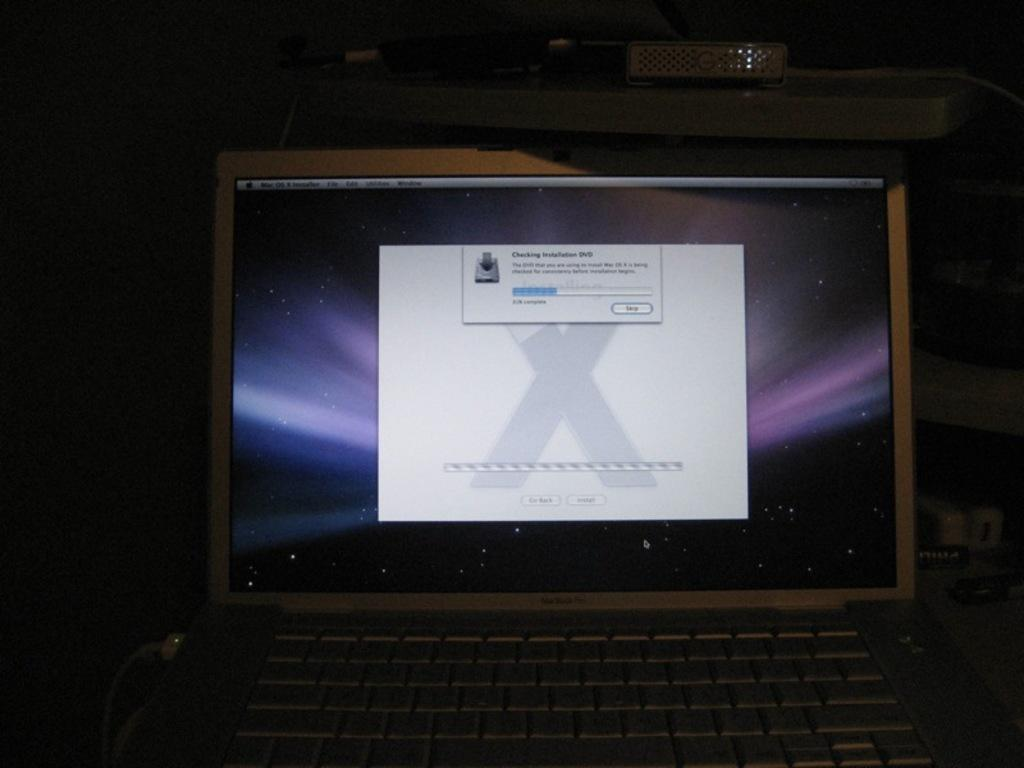Provide a one-sentence caption for the provided image. A laptop screen with a open window that says Checking Installation DVD. 